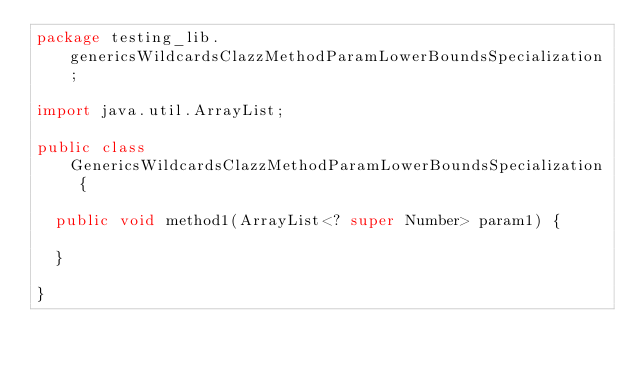Convert code to text. <code><loc_0><loc_0><loc_500><loc_500><_Java_>package testing_lib.genericsWildcardsClazzMethodParamLowerBoundsSpecialization;

import java.util.ArrayList;

public class GenericsWildcardsClazzMethodParamLowerBoundsSpecialization {
	
	public void method1(ArrayList<? super Number> param1) {
		
	}
	
}
</code> 